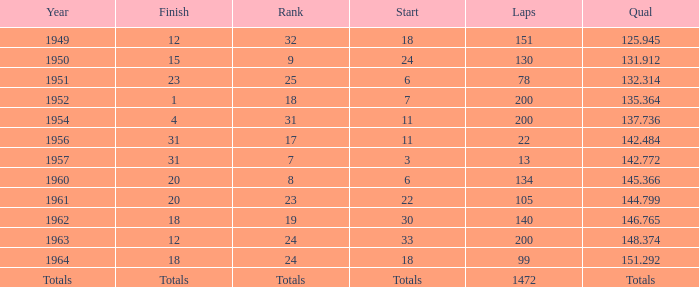Name the year for laps of 200 and rank of 24 1963.0. 